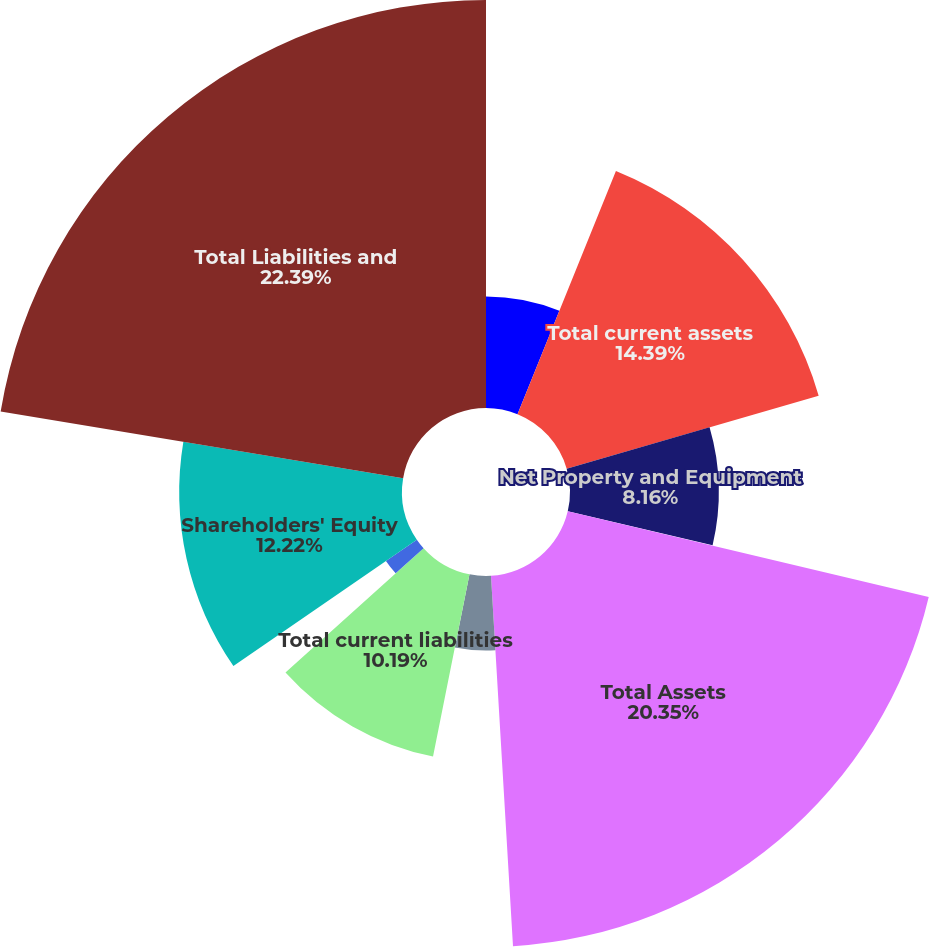Convert chart to OTSL. <chart><loc_0><loc_0><loc_500><loc_500><pie_chart><fcel>Other current assets<fcel>Total current assets<fcel>Net Property and Equipment<fcel>Other Assets<fcel>Total Assets<fcel>Accrued liabilities<fcel>Total current liabilities<fcel>Long-Term Liabilities<fcel>Shareholders' Equity<fcel>Total Liabilities and<nl><fcel>6.12%<fcel>14.39%<fcel>8.16%<fcel>0.03%<fcel>20.35%<fcel>4.09%<fcel>10.19%<fcel>2.06%<fcel>12.22%<fcel>22.38%<nl></chart> 